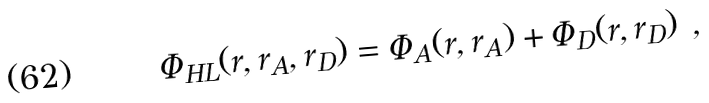<formula> <loc_0><loc_0><loc_500><loc_500>\Phi _ { H L } ( r , r _ { A } , r _ { D } ) = \Phi _ { A } ( r , r _ { A } ) + \Phi _ { D } ( r , r _ { D } ) \ ,</formula> 